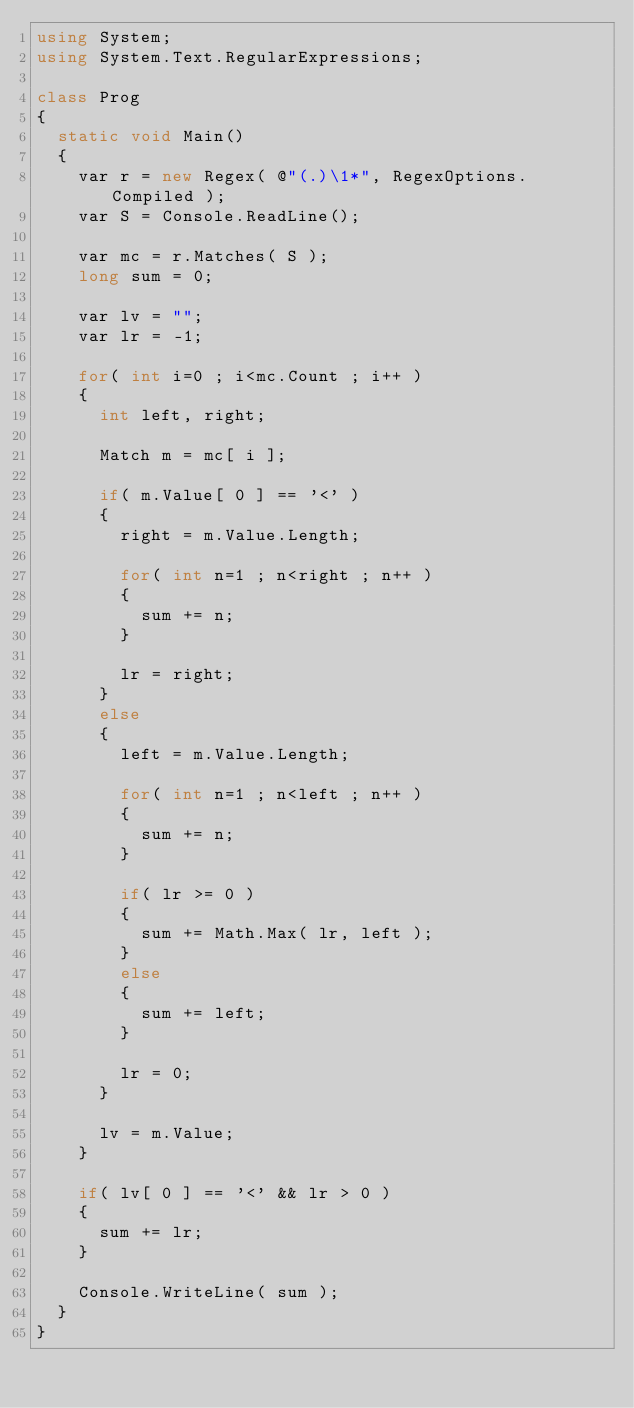<code> <loc_0><loc_0><loc_500><loc_500><_C#_>using System;
using System.Text.RegularExpressions;

class Prog
{
	static void Main()
	{
		var r = new Regex( @"(.)\1*", RegexOptions.Compiled );
		var S = Console.ReadLine();
		
		var mc = r.Matches( S );
		long sum = 0;
		
		var lv = "";
		var lr = -1;
		
		for( int i=0 ; i<mc.Count ; i++ )
		{
			int left, right;
			
			Match m = mc[ i ];
			
			if( m.Value[ 0 ] == '<' )
			{
				right = m.Value.Length;
				
				for( int n=1 ; n<right ; n++ )
				{
					sum += n;
				}
				
				lr = right;
			}
			else
			{
				left = m.Value.Length;
				
				for( int n=1 ; n<left ; n++ )
				{
					sum += n;
				}
				
				if( lr >= 0 )
				{
					sum += Math.Max( lr, left );
				}
				else
				{
					sum += left;
				}
				
				lr = 0;
			}
			
			lv = m.Value;
		}
		
		if( lv[ 0 ] == '<' && lr > 0 )
		{
			sum += lr;
		}
		
		Console.WriteLine( sum );
	}
}</code> 